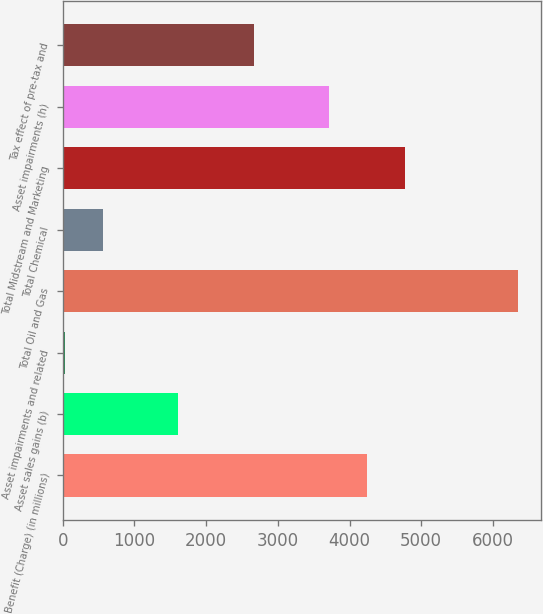<chart> <loc_0><loc_0><loc_500><loc_500><bar_chart><fcel>Benefit (Charge) (in millions)<fcel>Asset sales gains (b)<fcel>Asset impairments and related<fcel>Total Oil and Gas<fcel>Total Chemical<fcel>Total Midstream and Marketing<fcel>Asset impairments (h)<fcel>Tax effect of pre-tax and<nl><fcel>4247<fcel>1612<fcel>31<fcel>6355<fcel>558<fcel>4774<fcel>3720<fcel>2666<nl></chart> 